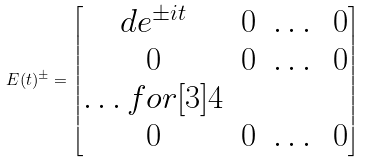<formula> <loc_0><loc_0><loc_500><loc_500>E ( t ) ^ { \pm } = \begin{bmatrix} d e ^ { \pm i t } & 0 & \dots & 0 \\ 0 & 0 & \dots & 0 \\ \hdots f o r [ 3 ] { 4 } \\ 0 & 0 & \dots & 0 \end{bmatrix}</formula> 